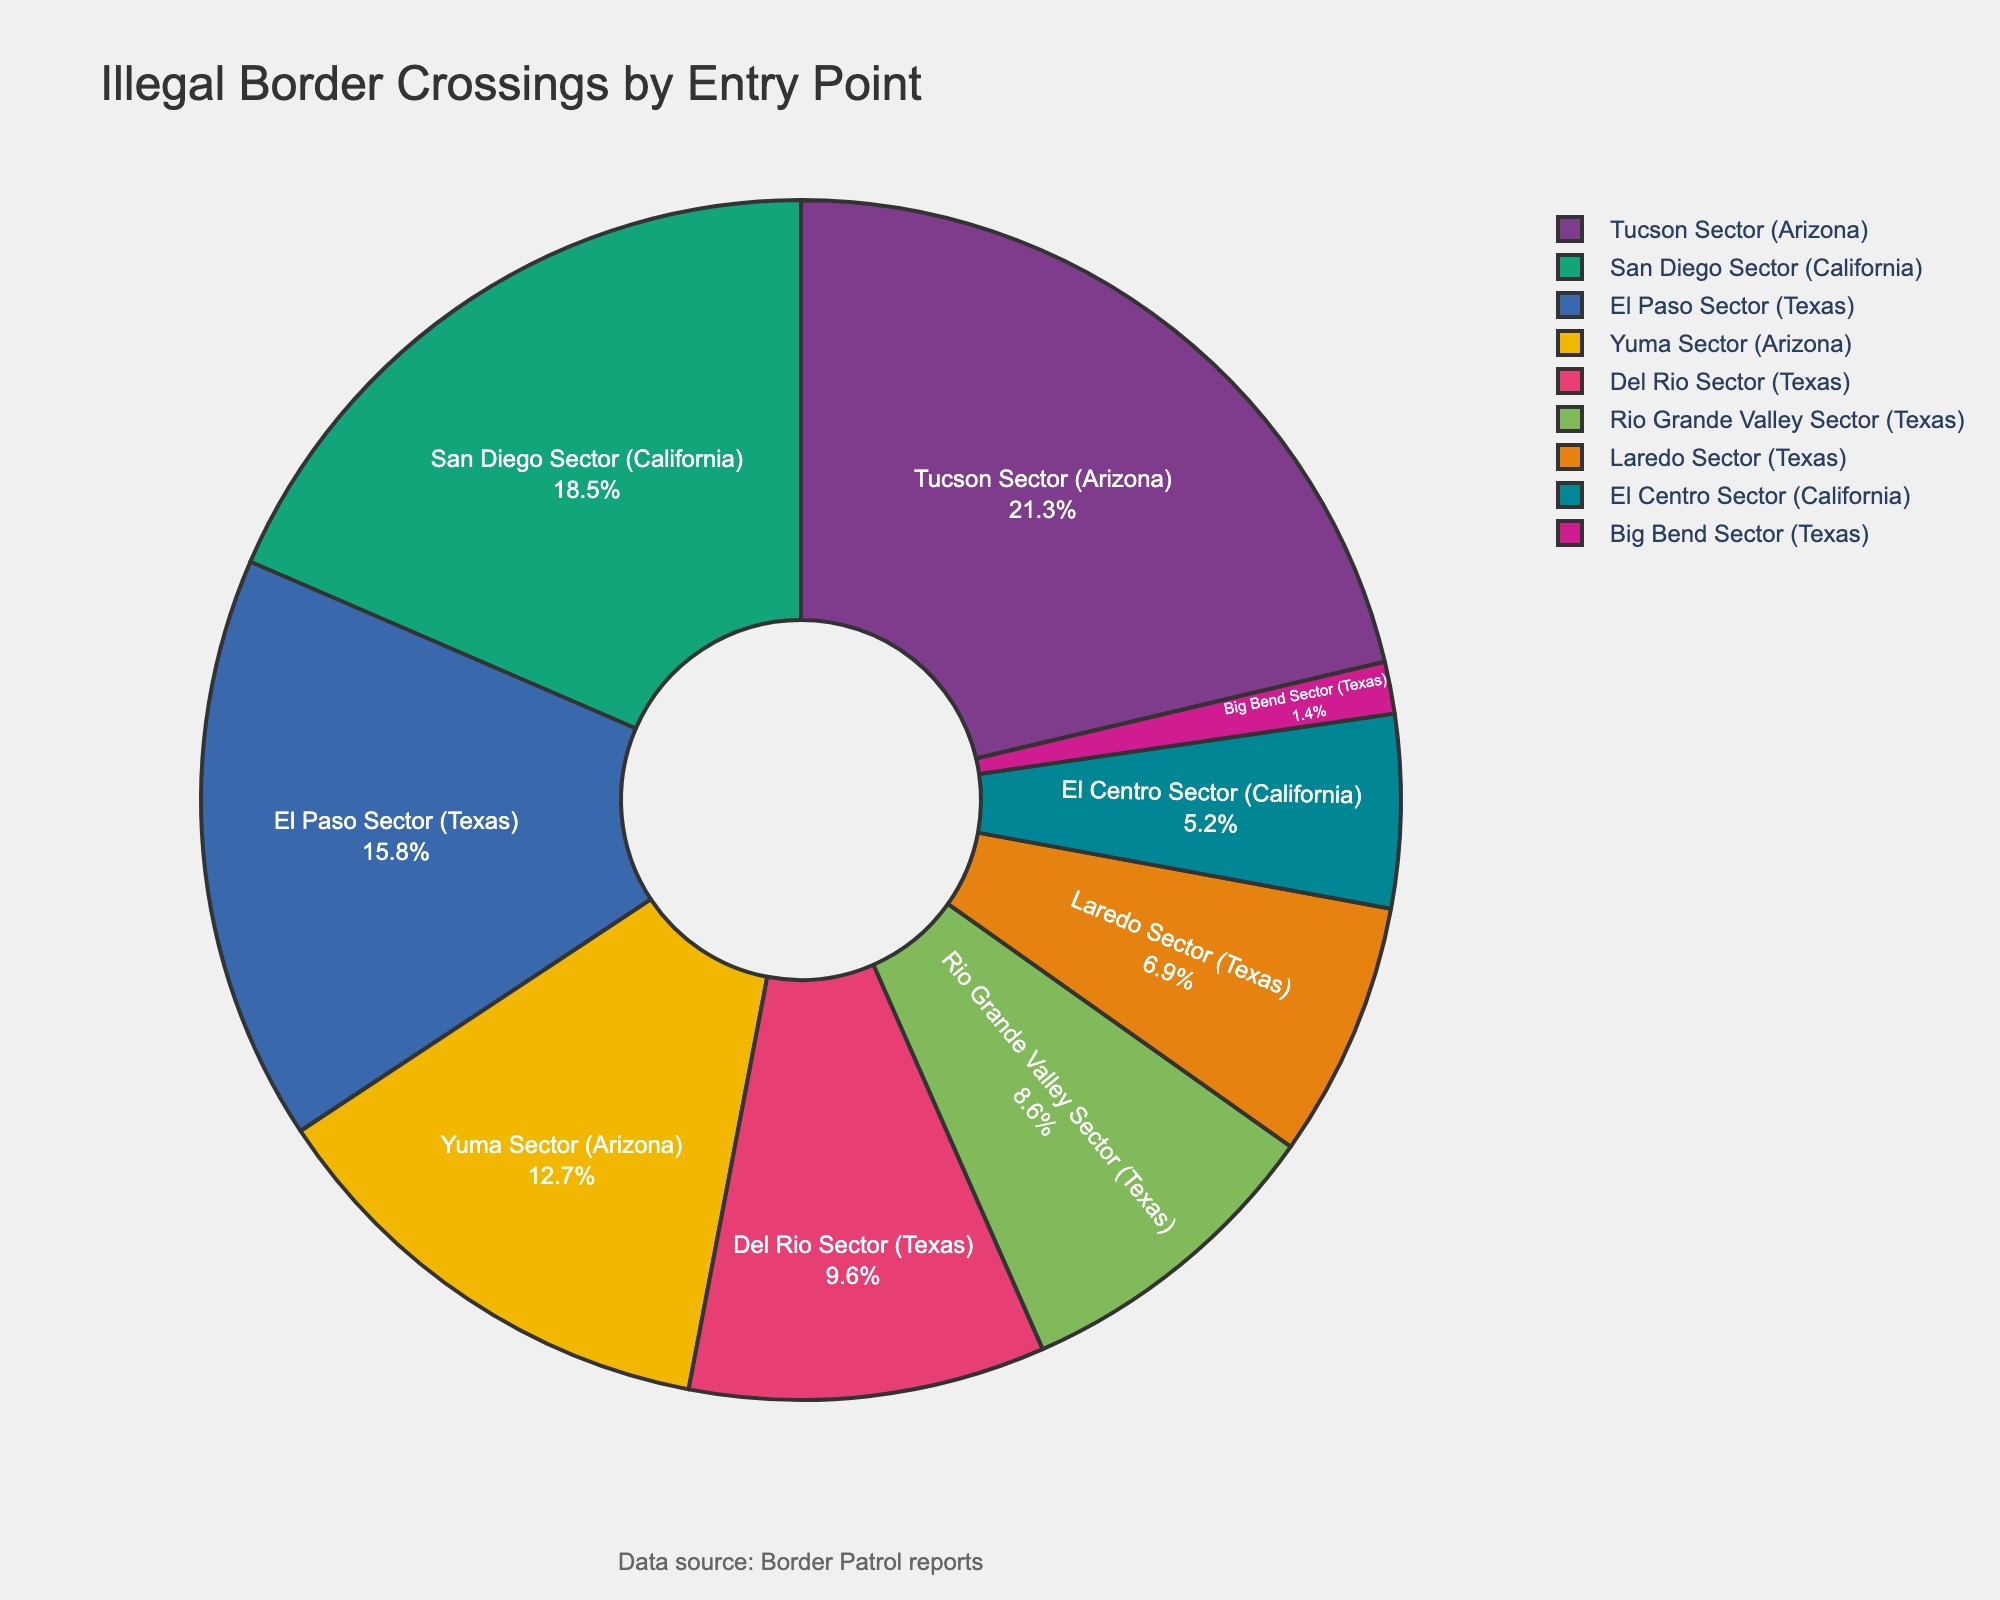What's the largest sector for illegal border crossings? From the figure, observe the sectors labeled with different percentages. The Tucson Sector (Arizona) has the highest percentage with 21.3%.
Answer: Tucson Sector (Arizona) Which two sectors in Texas together account for more than 24% of illegal border crossings? From the figure, identify the percentages for the Texas sectors. El Paso Sector has 15.8%, and Del Rio Sector has 9.6%. Together, their sum is 15.8% + 9.6% = 25.4%, which is more than 24%.
Answer: El Paso Sector and Del Rio Sector Which sector has the smallest percentage of illegal border crossings? The smallest percentage from the figure is observed in the Big Bend Sector (Texas) with 1.4%.
Answer: Big Bend Sector (Texas) What is the combined percentage of illegal border crossings for the California sectors? Add the percentages for the San Diego Sector (18.5%) and El Centro Sector (5.2%) from the chart. 18.5% + 5.2% = 23.7%.
Answer: 23.7% Which sector has a greater percentage of illegal border crossings, Rio Grande Valley Sector (Texas) or Yuma Sector (Arizona)? From the chart, the Rio Grande Valley Sector (Texas) accounts for 8.6%, while Yuma Sector (Arizona) accounts for 12.7%, making Yuma Sector greater.
Answer: Yuma Sector (Arizona) How many sectors have illegal border crossings less than 10%? From the figure, identify the sectors with percentages below 10%: El Centro Sector (5.2%), Big Bend Sector (1.4%), Del Rio Sector (9.6%), and Laredo Sector (6.9%), making a total of 4.
Answer: 4 What is the difference in illegal border crossing percentages between the Tucson Sector (Arizona) and the San Diego Sector (California)? From the chart, Tucson Sector has 21.3% and San Diego Sector has 18.5%. The difference is 21.3% - 18.5% = 2.8%.
Answer: 2.8% What sectors in Arizona together cover over 30% of illegal border crossings? From the pie chart, sum the percentages of the Arizona sectors: Yuma Sector (12.7%) and Tucson Sector (21.3%). Their combined percentage is 12.7% + 21.3% = 34%, which exceeds 30%.
Answer: Yuma Sector and Tucson Sector 